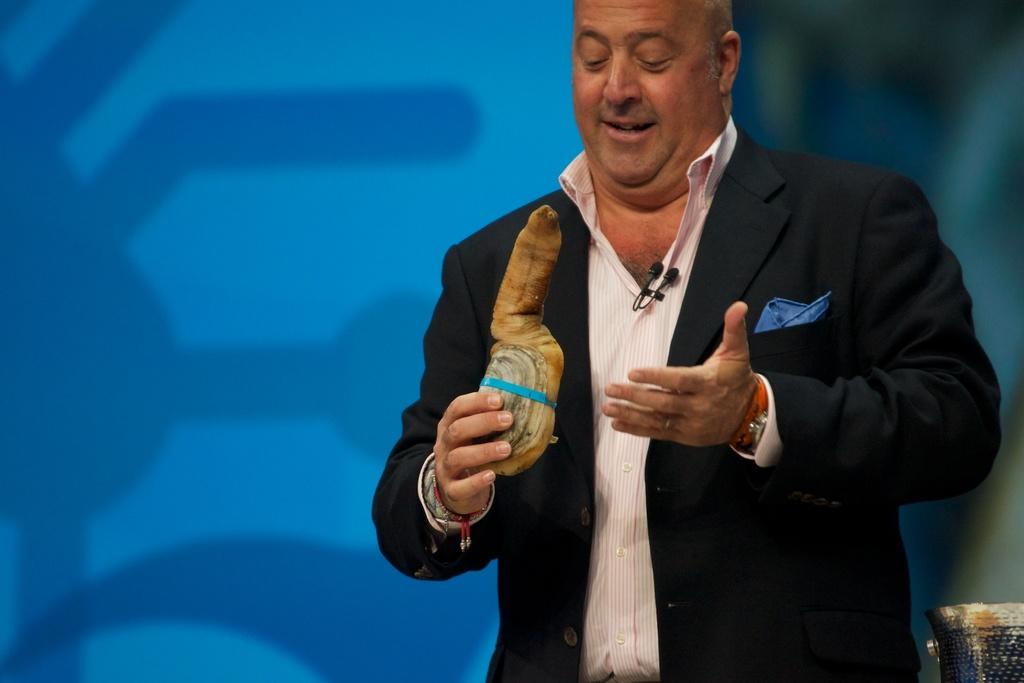Who is present in the image? There is a man in the image. Where is the man located in the image? The man is standing on the right side of the image. What color is the background of the image? The background of the image is blue in color. What type of pest can be seen crawling on the man's shoulder in the image? There is no pest present on the man's shoulder in the image. 